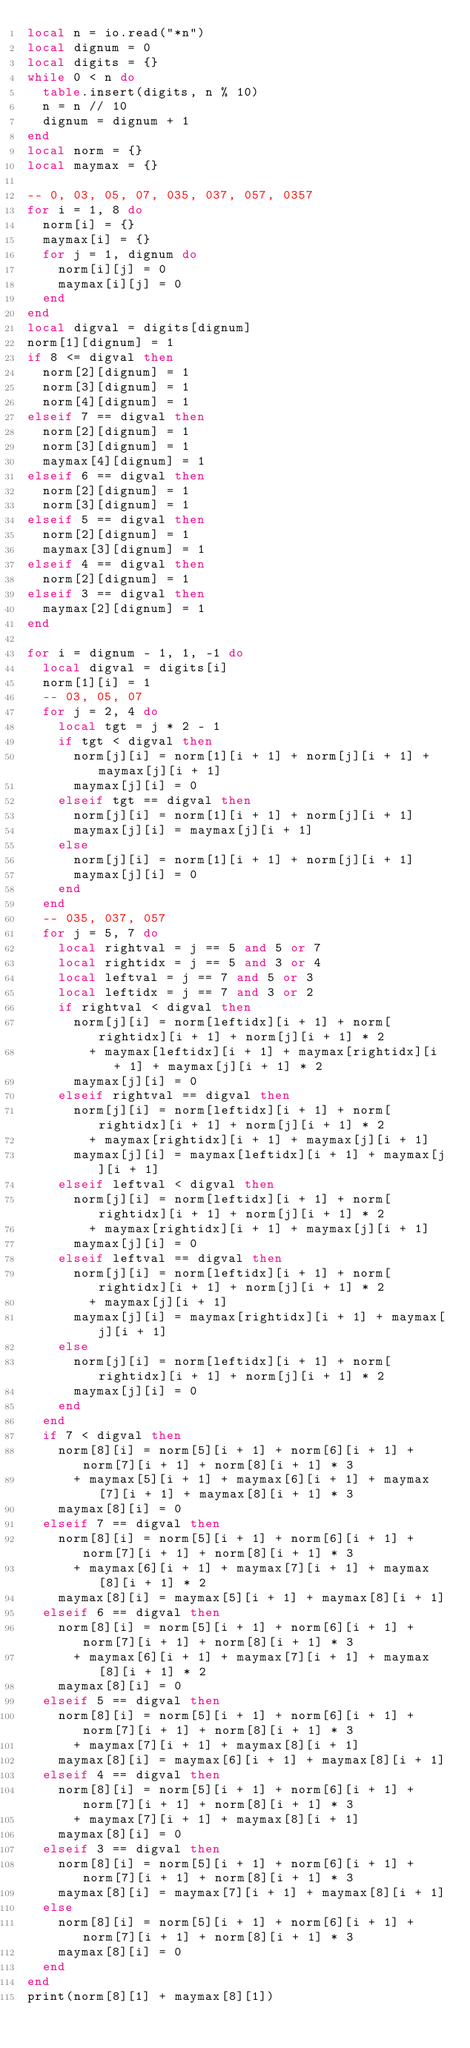<code> <loc_0><loc_0><loc_500><loc_500><_Lua_>local n = io.read("*n")
local dignum = 0
local digits = {}
while 0 < n do
  table.insert(digits, n % 10)
  n = n // 10
  dignum = dignum + 1
end
local norm = {}
local maymax = {}

-- 0, 03, 05, 07, 035, 037, 057, 0357
for i = 1, 8 do
  norm[i] = {}
  maymax[i] = {}
  for j = 1, dignum do
    norm[i][j] = 0
    maymax[i][j] = 0
  end
end
local digval = digits[dignum]
norm[1][dignum] = 1
if 8 <= digval then
  norm[2][dignum] = 1
  norm[3][dignum] = 1
  norm[4][dignum] = 1
elseif 7 == digval then
  norm[2][dignum] = 1
  norm[3][dignum] = 1
  maymax[4][dignum] = 1
elseif 6 == digval then
  norm[2][dignum] = 1
  norm[3][dignum] = 1
elseif 5 == digval then
  norm[2][dignum] = 1
  maymax[3][dignum] = 1
elseif 4 == digval then
  norm[2][dignum] = 1
elseif 3 == digval then
  maymax[2][dignum] = 1
end

for i = dignum - 1, 1, -1 do
  local digval = digits[i]
  norm[1][i] = 1
  -- 03, 05, 07
  for j = 2, 4 do
    local tgt = j * 2 - 1
    if tgt < digval then
      norm[j][i] = norm[1][i + 1] + norm[j][i + 1] + maymax[j][i + 1]
      maymax[j][i] = 0
    elseif tgt == digval then
      norm[j][i] = norm[1][i + 1] + norm[j][i + 1]
      maymax[j][i] = maymax[j][i + 1]
    else
      norm[j][i] = norm[1][i + 1] + norm[j][i + 1]
      maymax[j][i] = 0
    end
  end
  -- 035, 037, 057
  for j = 5, 7 do
    local rightval = j == 5 and 5 or 7
    local rightidx = j == 5 and 3 or 4
    local leftval = j == 7 and 5 or 3
    local leftidx = j == 7 and 3 or 2
    if rightval < digval then
      norm[j][i] = norm[leftidx][i + 1] + norm[rightidx][i + 1] + norm[j][i + 1] * 2
        + maymax[leftidx][i + 1] + maymax[rightidx][i + 1] + maymax[j][i + 1] * 2
      maymax[j][i] = 0
    elseif rightval == digval then
      norm[j][i] = norm[leftidx][i + 1] + norm[rightidx][i + 1] + norm[j][i + 1] * 2
        + maymax[rightidx][i + 1] + maymax[j][i + 1]
      maymax[j][i] = maymax[leftidx][i + 1] + maymax[j][i + 1]
    elseif leftval < digval then
      norm[j][i] = norm[leftidx][i + 1] + norm[rightidx][i + 1] + norm[j][i + 1] * 2
        + maymax[rightidx][i + 1] + maymax[j][i + 1]
      maymax[j][i] = 0
    elseif leftval == digval then
      norm[j][i] = norm[leftidx][i + 1] + norm[rightidx][i + 1] + norm[j][i + 1] * 2
        + maymax[j][i + 1]
      maymax[j][i] = maymax[rightidx][i + 1] + maymax[j][i + 1]
    else
      norm[j][i] = norm[leftidx][i + 1] + norm[rightidx][i + 1] + norm[j][i + 1] * 2
      maymax[j][i] = 0
    end
  end
  if 7 < digval then
    norm[8][i] = norm[5][i + 1] + norm[6][i + 1] + norm[7][i + 1] + norm[8][i + 1] * 3
      + maymax[5][i + 1] + maymax[6][i + 1] + maymax[7][i + 1] + maymax[8][i + 1] * 3
    maymax[8][i] = 0
  elseif 7 == digval then
    norm[8][i] = norm[5][i + 1] + norm[6][i + 1] + norm[7][i + 1] + norm[8][i + 1] * 3
      + maymax[6][i + 1] + maymax[7][i + 1] + maymax[8][i + 1] * 2
    maymax[8][i] = maymax[5][i + 1] + maymax[8][i + 1]
  elseif 6 == digval then
    norm[8][i] = norm[5][i + 1] + norm[6][i + 1] + norm[7][i + 1] + norm[8][i + 1] * 3
      + maymax[6][i + 1] + maymax[7][i + 1] + maymax[8][i + 1] * 2
    maymax[8][i] = 0
  elseif 5 == digval then
    norm[8][i] = norm[5][i + 1] + norm[6][i + 1] + norm[7][i + 1] + norm[8][i + 1] * 3
      + maymax[7][i + 1] + maymax[8][i + 1]
    maymax[8][i] = maymax[6][i + 1] + maymax[8][i + 1]
  elseif 4 == digval then
    norm[8][i] = norm[5][i + 1] + norm[6][i + 1] + norm[7][i + 1] + norm[8][i + 1] * 3
      + maymax[7][i + 1] + maymax[8][i + 1]
    maymax[8][i] = 0
  elseif 3 == digval then
    norm[8][i] = norm[5][i + 1] + norm[6][i + 1] + norm[7][i + 1] + norm[8][i + 1] * 3
    maymax[8][i] = maymax[7][i + 1] + maymax[8][i + 1]
  else
    norm[8][i] = norm[5][i + 1] + norm[6][i + 1] + norm[7][i + 1] + norm[8][i + 1] * 3
    maymax[8][i] = 0
  end
end
print(norm[8][1] + maymax[8][1])
</code> 